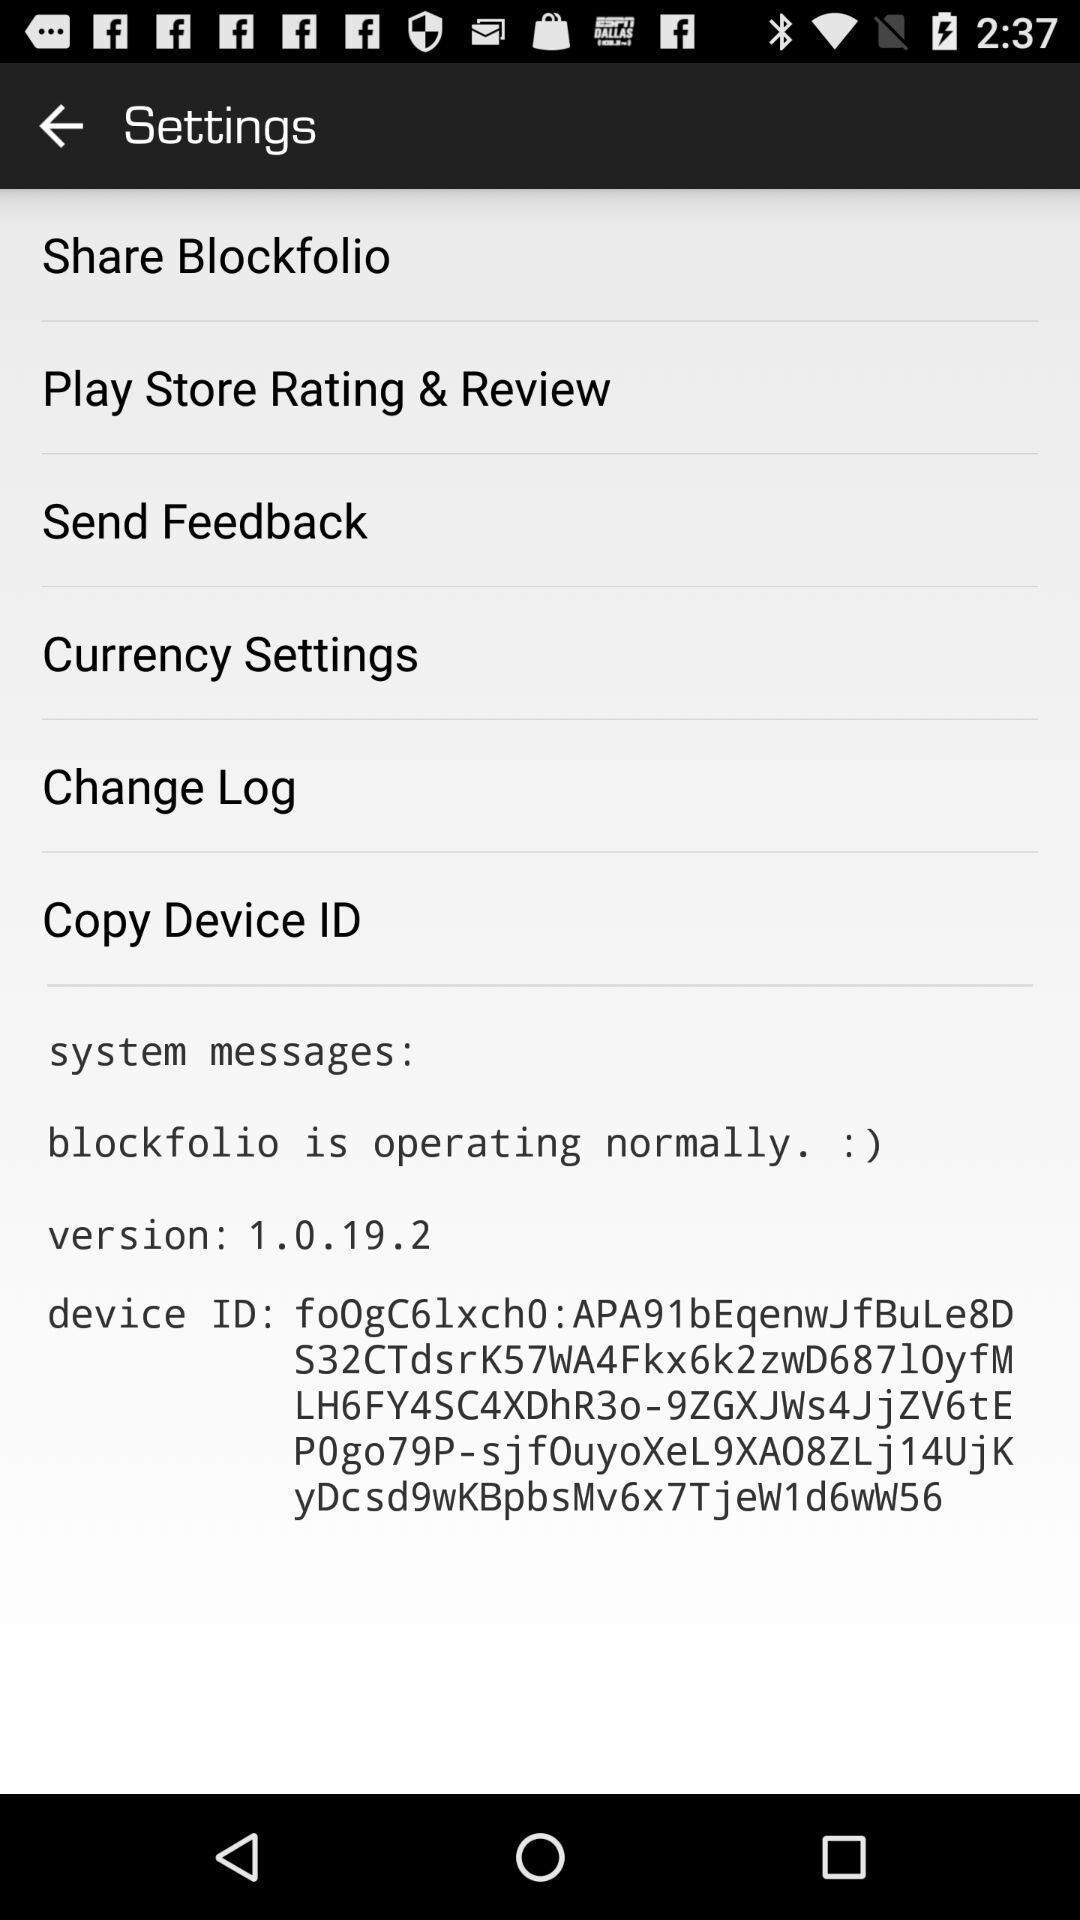Give me a narrative description of this picture. Page showing different options in settings. 